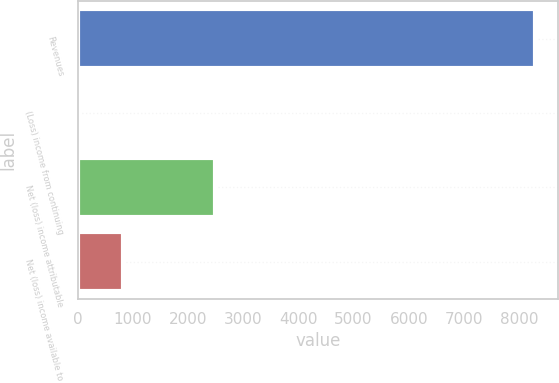<chart> <loc_0><loc_0><loc_500><loc_500><bar_chart><fcel>Revenues<fcel>(Loss) income from continuing<fcel>Net (loss) income attributable<fcel>Net (loss) income available to<nl><fcel>8292<fcel>0.28<fcel>2487.79<fcel>829.45<nl></chart> 